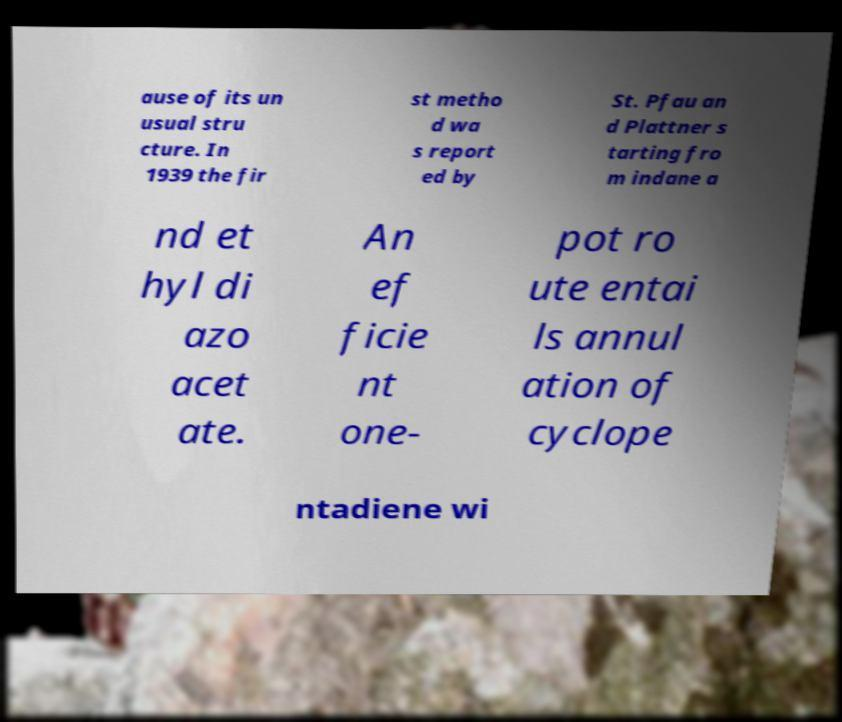Please read and relay the text visible in this image. What does it say? ause of its un usual stru cture. In 1939 the fir st metho d wa s report ed by St. Pfau an d Plattner s tarting fro m indane a nd et hyl di azo acet ate. An ef ficie nt one- pot ro ute entai ls annul ation of cyclope ntadiene wi 